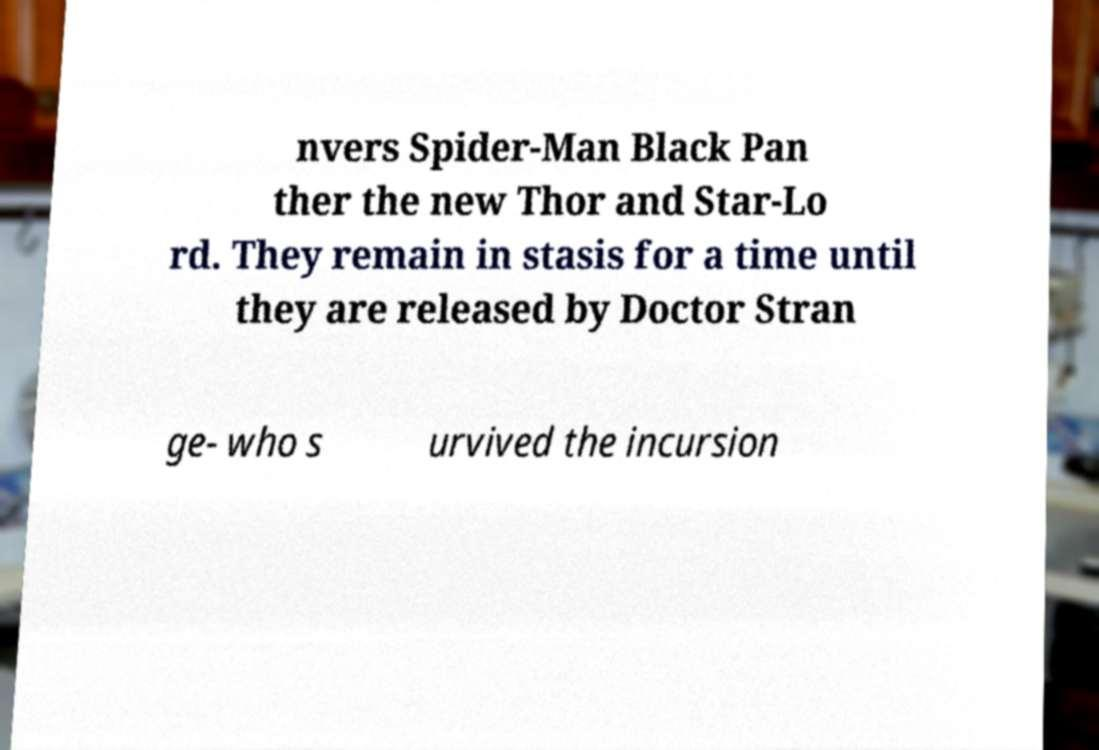Could you assist in decoding the text presented in this image and type it out clearly? nvers Spider-Man Black Pan ther the new Thor and Star-Lo rd. They remain in stasis for a time until they are released by Doctor Stran ge- who s urvived the incursion 